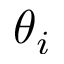Convert formula to latex. <formula><loc_0><loc_0><loc_500><loc_500>\theta _ { i }</formula> 